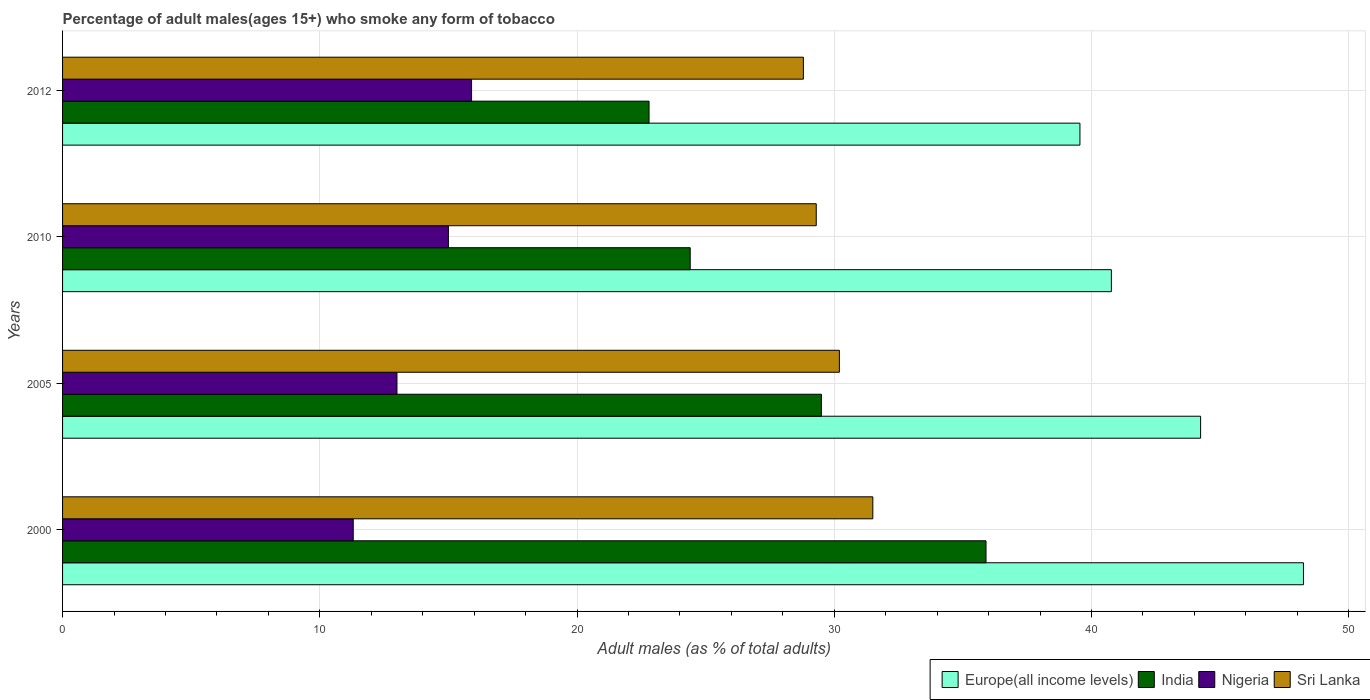How many different coloured bars are there?
Ensure brevity in your answer.  4. How many groups of bars are there?
Provide a short and direct response. 4. Are the number of bars on each tick of the Y-axis equal?
Give a very brief answer. Yes. What is the percentage of adult males who smoke in India in 2012?
Your response must be concise. 22.8. Across all years, what is the maximum percentage of adult males who smoke in India?
Offer a terse response. 35.9. Across all years, what is the minimum percentage of adult males who smoke in Europe(all income levels)?
Ensure brevity in your answer.  39.55. What is the total percentage of adult males who smoke in Nigeria in the graph?
Ensure brevity in your answer.  55.2. What is the difference between the percentage of adult males who smoke in Sri Lanka in 2000 and that in 2012?
Your response must be concise. 2.7. What is the difference between the percentage of adult males who smoke in Europe(all income levels) in 2005 and the percentage of adult males who smoke in Sri Lanka in 2012?
Your response must be concise. 15.44. What is the average percentage of adult males who smoke in Sri Lanka per year?
Give a very brief answer. 29.95. In the year 2010, what is the difference between the percentage of adult males who smoke in Nigeria and percentage of adult males who smoke in Europe(all income levels)?
Provide a succinct answer. -25.77. What is the ratio of the percentage of adult males who smoke in Sri Lanka in 2000 to that in 2005?
Provide a succinct answer. 1.04. Is the percentage of adult males who smoke in Nigeria in 2000 less than that in 2005?
Offer a very short reply. Yes. What is the difference between the highest and the second highest percentage of adult males who smoke in Sri Lanka?
Offer a terse response. 1.3. What is the difference between the highest and the lowest percentage of adult males who smoke in Sri Lanka?
Give a very brief answer. 2.7. In how many years, is the percentage of adult males who smoke in Sri Lanka greater than the average percentage of adult males who smoke in Sri Lanka taken over all years?
Ensure brevity in your answer.  2. What does the 4th bar from the top in 2010 represents?
Your answer should be very brief. Europe(all income levels). Is it the case that in every year, the sum of the percentage of adult males who smoke in Sri Lanka and percentage of adult males who smoke in Nigeria is greater than the percentage of adult males who smoke in Europe(all income levels)?
Make the answer very short. No. How many bars are there?
Keep it short and to the point. 16. Are all the bars in the graph horizontal?
Provide a succinct answer. Yes. How many years are there in the graph?
Offer a very short reply. 4. Are the values on the major ticks of X-axis written in scientific E-notation?
Your answer should be compact. No. Does the graph contain any zero values?
Provide a short and direct response. No. Does the graph contain grids?
Offer a terse response. Yes. Where does the legend appear in the graph?
Your response must be concise. Bottom right. How are the legend labels stacked?
Offer a terse response. Horizontal. What is the title of the graph?
Make the answer very short. Percentage of adult males(ages 15+) who smoke any form of tobacco. What is the label or title of the X-axis?
Provide a short and direct response. Adult males (as % of total adults). What is the label or title of the Y-axis?
Offer a very short reply. Years. What is the Adult males (as % of total adults) in Europe(all income levels) in 2000?
Give a very brief answer. 48.24. What is the Adult males (as % of total adults) in India in 2000?
Give a very brief answer. 35.9. What is the Adult males (as % of total adults) of Sri Lanka in 2000?
Offer a terse response. 31.5. What is the Adult males (as % of total adults) of Europe(all income levels) in 2005?
Make the answer very short. 44.24. What is the Adult males (as % of total adults) of India in 2005?
Your response must be concise. 29.5. What is the Adult males (as % of total adults) of Nigeria in 2005?
Ensure brevity in your answer.  13. What is the Adult males (as % of total adults) of Sri Lanka in 2005?
Provide a succinct answer. 30.2. What is the Adult males (as % of total adults) in Europe(all income levels) in 2010?
Keep it short and to the point. 40.77. What is the Adult males (as % of total adults) in India in 2010?
Provide a succinct answer. 24.4. What is the Adult males (as % of total adults) in Sri Lanka in 2010?
Your response must be concise. 29.3. What is the Adult males (as % of total adults) of Europe(all income levels) in 2012?
Your response must be concise. 39.55. What is the Adult males (as % of total adults) of India in 2012?
Make the answer very short. 22.8. What is the Adult males (as % of total adults) of Sri Lanka in 2012?
Give a very brief answer. 28.8. Across all years, what is the maximum Adult males (as % of total adults) in Europe(all income levels)?
Provide a short and direct response. 48.24. Across all years, what is the maximum Adult males (as % of total adults) in India?
Keep it short and to the point. 35.9. Across all years, what is the maximum Adult males (as % of total adults) of Nigeria?
Ensure brevity in your answer.  15.9. Across all years, what is the maximum Adult males (as % of total adults) of Sri Lanka?
Offer a terse response. 31.5. Across all years, what is the minimum Adult males (as % of total adults) of Europe(all income levels)?
Your response must be concise. 39.55. Across all years, what is the minimum Adult males (as % of total adults) of India?
Provide a short and direct response. 22.8. Across all years, what is the minimum Adult males (as % of total adults) of Nigeria?
Give a very brief answer. 11.3. Across all years, what is the minimum Adult males (as % of total adults) in Sri Lanka?
Your answer should be very brief. 28.8. What is the total Adult males (as % of total adults) in Europe(all income levels) in the graph?
Provide a short and direct response. 172.81. What is the total Adult males (as % of total adults) in India in the graph?
Your answer should be very brief. 112.6. What is the total Adult males (as % of total adults) of Nigeria in the graph?
Provide a short and direct response. 55.2. What is the total Adult males (as % of total adults) in Sri Lanka in the graph?
Ensure brevity in your answer.  119.8. What is the difference between the Adult males (as % of total adults) of Europe(all income levels) in 2000 and that in 2005?
Ensure brevity in your answer.  4. What is the difference between the Adult males (as % of total adults) in Sri Lanka in 2000 and that in 2005?
Provide a succinct answer. 1.3. What is the difference between the Adult males (as % of total adults) in Europe(all income levels) in 2000 and that in 2010?
Ensure brevity in your answer.  7.47. What is the difference between the Adult males (as % of total adults) of India in 2000 and that in 2010?
Your response must be concise. 11.5. What is the difference between the Adult males (as % of total adults) in Sri Lanka in 2000 and that in 2010?
Your answer should be compact. 2.2. What is the difference between the Adult males (as % of total adults) in Europe(all income levels) in 2000 and that in 2012?
Your response must be concise. 8.69. What is the difference between the Adult males (as % of total adults) of India in 2000 and that in 2012?
Offer a very short reply. 13.1. What is the difference between the Adult males (as % of total adults) in Nigeria in 2000 and that in 2012?
Your answer should be compact. -4.6. What is the difference between the Adult males (as % of total adults) in Europe(all income levels) in 2005 and that in 2010?
Offer a terse response. 3.47. What is the difference between the Adult males (as % of total adults) of Europe(all income levels) in 2005 and that in 2012?
Make the answer very short. 4.69. What is the difference between the Adult males (as % of total adults) in Sri Lanka in 2005 and that in 2012?
Your response must be concise. 1.4. What is the difference between the Adult males (as % of total adults) of Europe(all income levels) in 2010 and that in 2012?
Your answer should be very brief. 1.22. What is the difference between the Adult males (as % of total adults) of India in 2010 and that in 2012?
Offer a terse response. 1.6. What is the difference between the Adult males (as % of total adults) of Sri Lanka in 2010 and that in 2012?
Offer a terse response. 0.5. What is the difference between the Adult males (as % of total adults) of Europe(all income levels) in 2000 and the Adult males (as % of total adults) of India in 2005?
Your answer should be compact. 18.74. What is the difference between the Adult males (as % of total adults) in Europe(all income levels) in 2000 and the Adult males (as % of total adults) in Nigeria in 2005?
Make the answer very short. 35.24. What is the difference between the Adult males (as % of total adults) in Europe(all income levels) in 2000 and the Adult males (as % of total adults) in Sri Lanka in 2005?
Make the answer very short. 18.04. What is the difference between the Adult males (as % of total adults) in India in 2000 and the Adult males (as % of total adults) in Nigeria in 2005?
Keep it short and to the point. 22.9. What is the difference between the Adult males (as % of total adults) of Nigeria in 2000 and the Adult males (as % of total adults) of Sri Lanka in 2005?
Provide a short and direct response. -18.9. What is the difference between the Adult males (as % of total adults) of Europe(all income levels) in 2000 and the Adult males (as % of total adults) of India in 2010?
Ensure brevity in your answer.  23.84. What is the difference between the Adult males (as % of total adults) in Europe(all income levels) in 2000 and the Adult males (as % of total adults) in Nigeria in 2010?
Offer a terse response. 33.24. What is the difference between the Adult males (as % of total adults) of Europe(all income levels) in 2000 and the Adult males (as % of total adults) of Sri Lanka in 2010?
Your answer should be very brief. 18.94. What is the difference between the Adult males (as % of total adults) in India in 2000 and the Adult males (as % of total adults) in Nigeria in 2010?
Offer a very short reply. 20.9. What is the difference between the Adult males (as % of total adults) in India in 2000 and the Adult males (as % of total adults) in Sri Lanka in 2010?
Provide a short and direct response. 6.6. What is the difference between the Adult males (as % of total adults) of Europe(all income levels) in 2000 and the Adult males (as % of total adults) of India in 2012?
Provide a short and direct response. 25.44. What is the difference between the Adult males (as % of total adults) in Europe(all income levels) in 2000 and the Adult males (as % of total adults) in Nigeria in 2012?
Provide a short and direct response. 32.34. What is the difference between the Adult males (as % of total adults) of Europe(all income levels) in 2000 and the Adult males (as % of total adults) of Sri Lanka in 2012?
Your answer should be very brief. 19.44. What is the difference between the Adult males (as % of total adults) of Nigeria in 2000 and the Adult males (as % of total adults) of Sri Lanka in 2012?
Provide a succinct answer. -17.5. What is the difference between the Adult males (as % of total adults) of Europe(all income levels) in 2005 and the Adult males (as % of total adults) of India in 2010?
Give a very brief answer. 19.84. What is the difference between the Adult males (as % of total adults) in Europe(all income levels) in 2005 and the Adult males (as % of total adults) in Nigeria in 2010?
Your answer should be compact. 29.24. What is the difference between the Adult males (as % of total adults) of Europe(all income levels) in 2005 and the Adult males (as % of total adults) of Sri Lanka in 2010?
Provide a short and direct response. 14.94. What is the difference between the Adult males (as % of total adults) of Nigeria in 2005 and the Adult males (as % of total adults) of Sri Lanka in 2010?
Offer a very short reply. -16.3. What is the difference between the Adult males (as % of total adults) in Europe(all income levels) in 2005 and the Adult males (as % of total adults) in India in 2012?
Offer a terse response. 21.44. What is the difference between the Adult males (as % of total adults) of Europe(all income levels) in 2005 and the Adult males (as % of total adults) of Nigeria in 2012?
Your answer should be very brief. 28.34. What is the difference between the Adult males (as % of total adults) of Europe(all income levels) in 2005 and the Adult males (as % of total adults) of Sri Lanka in 2012?
Provide a succinct answer. 15.44. What is the difference between the Adult males (as % of total adults) in India in 2005 and the Adult males (as % of total adults) in Sri Lanka in 2012?
Your answer should be very brief. 0.7. What is the difference between the Adult males (as % of total adults) in Nigeria in 2005 and the Adult males (as % of total adults) in Sri Lanka in 2012?
Your answer should be compact. -15.8. What is the difference between the Adult males (as % of total adults) in Europe(all income levels) in 2010 and the Adult males (as % of total adults) in India in 2012?
Offer a very short reply. 17.97. What is the difference between the Adult males (as % of total adults) of Europe(all income levels) in 2010 and the Adult males (as % of total adults) of Nigeria in 2012?
Provide a succinct answer. 24.87. What is the difference between the Adult males (as % of total adults) in Europe(all income levels) in 2010 and the Adult males (as % of total adults) in Sri Lanka in 2012?
Your response must be concise. 11.97. What is the difference between the Adult males (as % of total adults) of India in 2010 and the Adult males (as % of total adults) of Nigeria in 2012?
Keep it short and to the point. 8.5. What is the difference between the Adult males (as % of total adults) in India in 2010 and the Adult males (as % of total adults) in Sri Lanka in 2012?
Provide a short and direct response. -4.4. What is the difference between the Adult males (as % of total adults) of Nigeria in 2010 and the Adult males (as % of total adults) of Sri Lanka in 2012?
Your answer should be very brief. -13.8. What is the average Adult males (as % of total adults) in Europe(all income levels) per year?
Offer a terse response. 43.2. What is the average Adult males (as % of total adults) of India per year?
Make the answer very short. 28.15. What is the average Adult males (as % of total adults) of Nigeria per year?
Provide a succinct answer. 13.8. What is the average Adult males (as % of total adults) of Sri Lanka per year?
Give a very brief answer. 29.95. In the year 2000, what is the difference between the Adult males (as % of total adults) of Europe(all income levels) and Adult males (as % of total adults) of India?
Your response must be concise. 12.34. In the year 2000, what is the difference between the Adult males (as % of total adults) in Europe(all income levels) and Adult males (as % of total adults) in Nigeria?
Offer a very short reply. 36.94. In the year 2000, what is the difference between the Adult males (as % of total adults) of Europe(all income levels) and Adult males (as % of total adults) of Sri Lanka?
Provide a succinct answer. 16.74. In the year 2000, what is the difference between the Adult males (as % of total adults) of India and Adult males (as % of total adults) of Nigeria?
Offer a terse response. 24.6. In the year 2000, what is the difference between the Adult males (as % of total adults) of Nigeria and Adult males (as % of total adults) of Sri Lanka?
Your response must be concise. -20.2. In the year 2005, what is the difference between the Adult males (as % of total adults) of Europe(all income levels) and Adult males (as % of total adults) of India?
Provide a succinct answer. 14.74. In the year 2005, what is the difference between the Adult males (as % of total adults) in Europe(all income levels) and Adult males (as % of total adults) in Nigeria?
Offer a very short reply. 31.24. In the year 2005, what is the difference between the Adult males (as % of total adults) of Europe(all income levels) and Adult males (as % of total adults) of Sri Lanka?
Offer a terse response. 14.04. In the year 2005, what is the difference between the Adult males (as % of total adults) of Nigeria and Adult males (as % of total adults) of Sri Lanka?
Give a very brief answer. -17.2. In the year 2010, what is the difference between the Adult males (as % of total adults) of Europe(all income levels) and Adult males (as % of total adults) of India?
Your response must be concise. 16.37. In the year 2010, what is the difference between the Adult males (as % of total adults) of Europe(all income levels) and Adult males (as % of total adults) of Nigeria?
Make the answer very short. 25.77. In the year 2010, what is the difference between the Adult males (as % of total adults) of Europe(all income levels) and Adult males (as % of total adults) of Sri Lanka?
Offer a terse response. 11.47. In the year 2010, what is the difference between the Adult males (as % of total adults) in Nigeria and Adult males (as % of total adults) in Sri Lanka?
Provide a succinct answer. -14.3. In the year 2012, what is the difference between the Adult males (as % of total adults) in Europe(all income levels) and Adult males (as % of total adults) in India?
Offer a very short reply. 16.75. In the year 2012, what is the difference between the Adult males (as % of total adults) in Europe(all income levels) and Adult males (as % of total adults) in Nigeria?
Give a very brief answer. 23.65. In the year 2012, what is the difference between the Adult males (as % of total adults) in Europe(all income levels) and Adult males (as % of total adults) in Sri Lanka?
Your answer should be compact. 10.75. What is the ratio of the Adult males (as % of total adults) in Europe(all income levels) in 2000 to that in 2005?
Your answer should be very brief. 1.09. What is the ratio of the Adult males (as % of total adults) in India in 2000 to that in 2005?
Your answer should be compact. 1.22. What is the ratio of the Adult males (as % of total adults) of Nigeria in 2000 to that in 2005?
Keep it short and to the point. 0.87. What is the ratio of the Adult males (as % of total adults) of Sri Lanka in 2000 to that in 2005?
Give a very brief answer. 1.04. What is the ratio of the Adult males (as % of total adults) of Europe(all income levels) in 2000 to that in 2010?
Keep it short and to the point. 1.18. What is the ratio of the Adult males (as % of total adults) in India in 2000 to that in 2010?
Provide a succinct answer. 1.47. What is the ratio of the Adult males (as % of total adults) in Nigeria in 2000 to that in 2010?
Your answer should be very brief. 0.75. What is the ratio of the Adult males (as % of total adults) in Sri Lanka in 2000 to that in 2010?
Your answer should be compact. 1.08. What is the ratio of the Adult males (as % of total adults) in Europe(all income levels) in 2000 to that in 2012?
Offer a very short reply. 1.22. What is the ratio of the Adult males (as % of total adults) of India in 2000 to that in 2012?
Give a very brief answer. 1.57. What is the ratio of the Adult males (as % of total adults) of Nigeria in 2000 to that in 2012?
Provide a succinct answer. 0.71. What is the ratio of the Adult males (as % of total adults) in Sri Lanka in 2000 to that in 2012?
Offer a very short reply. 1.09. What is the ratio of the Adult males (as % of total adults) in Europe(all income levels) in 2005 to that in 2010?
Your answer should be very brief. 1.09. What is the ratio of the Adult males (as % of total adults) of India in 2005 to that in 2010?
Offer a terse response. 1.21. What is the ratio of the Adult males (as % of total adults) of Nigeria in 2005 to that in 2010?
Offer a terse response. 0.87. What is the ratio of the Adult males (as % of total adults) in Sri Lanka in 2005 to that in 2010?
Your answer should be compact. 1.03. What is the ratio of the Adult males (as % of total adults) in Europe(all income levels) in 2005 to that in 2012?
Provide a short and direct response. 1.12. What is the ratio of the Adult males (as % of total adults) in India in 2005 to that in 2012?
Ensure brevity in your answer.  1.29. What is the ratio of the Adult males (as % of total adults) in Nigeria in 2005 to that in 2012?
Your response must be concise. 0.82. What is the ratio of the Adult males (as % of total adults) in Sri Lanka in 2005 to that in 2012?
Give a very brief answer. 1.05. What is the ratio of the Adult males (as % of total adults) in Europe(all income levels) in 2010 to that in 2012?
Your answer should be compact. 1.03. What is the ratio of the Adult males (as % of total adults) in India in 2010 to that in 2012?
Offer a very short reply. 1.07. What is the ratio of the Adult males (as % of total adults) in Nigeria in 2010 to that in 2012?
Your answer should be compact. 0.94. What is the ratio of the Adult males (as % of total adults) in Sri Lanka in 2010 to that in 2012?
Offer a very short reply. 1.02. What is the difference between the highest and the second highest Adult males (as % of total adults) of Europe(all income levels)?
Your response must be concise. 4. What is the difference between the highest and the second highest Adult males (as % of total adults) of India?
Your answer should be compact. 6.4. What is the difference between the highest and the lowest Adult males (as % of total adults) of Europe(all income levels)?
Your response must be concise. 8.69. What is the difference between the highest and the lowest Adult males (as % of total adults) in India?
Keep it short and to the point. 13.1. 